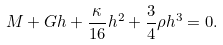Convert formula to latex. <formula><loc_0><loc_0><loc_500><loc_500>M + G h + \frac { \kappa } { 1 6 } h ^ { 2 } + \frac { 3 } { 4 } \rho h ^ { 3 } = 0 .</formula> 